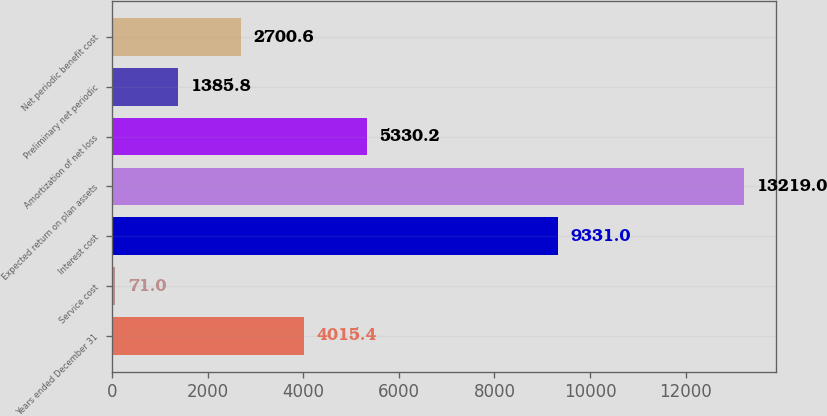Convert chart to OTSL. <chart><loc_0><loc_0><loc_500><loc_500><bar_chart><fcel>Years ended December 31<fcel>Service cost<fcel>Interest cost<fcel>Expected return on plan assets<fcel>Amortization of net loss<fcel>Preliminary net periodic<fcel>Net periodic benefit cost<nl><fcel>4015.4<fcel>71<fcel>9331<fcel>13219<fcel>5330.2<fcel>1385.8<fcel>2700.6<nl></chart> 